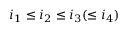Convert formula to latex. <formula><loc_0><loc_0><loc_500><loc_500>i _ { 1 } \leq i _ { 2 } \leq i _ { 3 } ( \leq i _ { 4 } )</formula> 